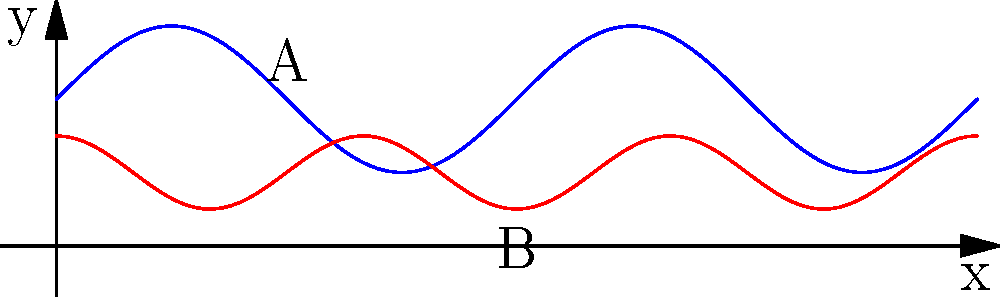In translating an abstract brush stroke to a vector path for scalable branding, you've created two parametric equations: $x(t) = t$ and $y(t) = 0.5\sin(2t) + 1$ for the blue curve, and $x(t) = t$ and $y(t) = 0.25\cos(3t) + 0.5$ for the red curve, where $0 \leq t \leq 2\pi$. What is the y-coordinate of point A minus the y-coordinate of point B? To solve this problem, we need to follow these steps:

1. Identify the t-value for point A on the blue curve:
   Point A is at $t = \pi/2$ on the blue curve.

2. Calculate the y-coordinate of point A:
   $y_A = 0.5\sin(2(\pi/2)) + 1$
   $y_A = 0.5\sin(\pi) + 1$
   $y_A = 0 + 1 = 1$

3. Identify the t-value for point B on the red curve:
   Point B is at $t = \pi$ on the red curve.

4. Calculate the y-coordinate of point B:
   $y_B = 0.25\cos(3\pi) + 0.5$
   $y_B = 0.25(-1) + 0.5$
   $y_B = -0.25 + 0.5 = 0.25$

5. Calculate the difference between y-coordinates:
   Difference = $y_A - y_B = 1 - 0.25 = 0.75$
Answer: 0.75 